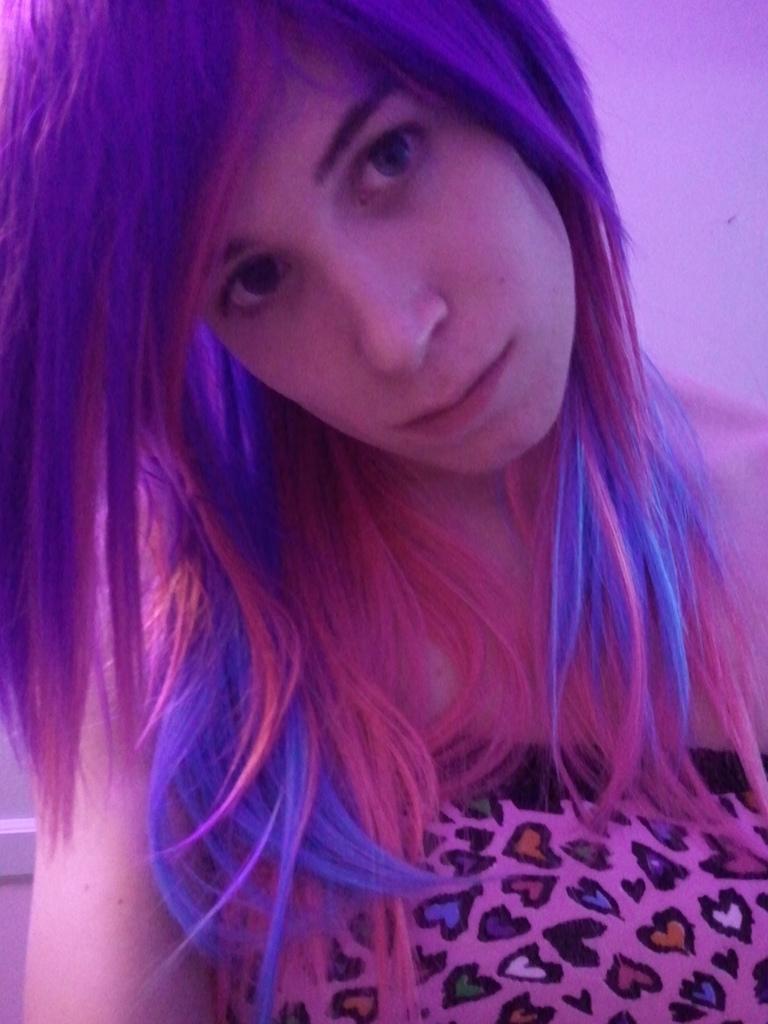Please provide a concise description of this image. In this picture we can see a woman and in the background we can see the wall. 